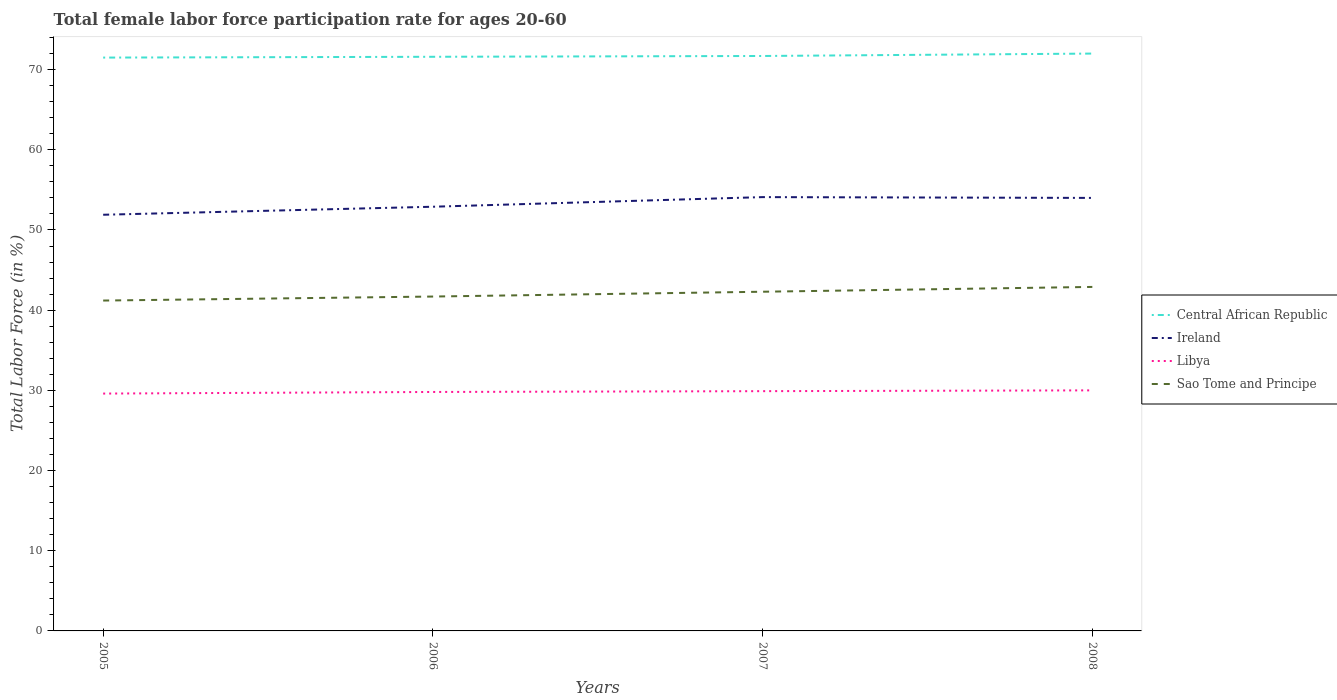How many different coloured lines are there?
Your answer should be compact. 4. Does the line corresponding to Ireland intersect with the line corresponding to Sao Tome and Principe?
Your response must be concise. No. Across all years, what is the maximum female labor force participation rate in Central African Republic?
Give a very brief answer. 71.5. What is the total female labor force participation rate in Sao Tome and Principe in the graph?
Offer a terse response. -0.5. What is the difference between the highest and the second highest female labor force participation rate in Sao Tome and Principe?
Your response must be concise. 1.7. Is the female labor force participation rate in Central African Republic strictly greater than the female labor force participation rate in Ireland over the years?
Provide a short and direct response. No. How many lines are there?
Your answer should be very brief. 4. How many years are there in the graph?
Offer a terse response. 4. How are the legend labels stacked?
Your answer should be compact. Vertical. What is the title of the graph?
Your answer should be very brief. Total female labor force participation rate for ages 20-60. Does "Indonesia" appear as one of the legend labels in the graph?
Provide a short and direct response. No. What is the label or title of the X-axis?
Give a very brief answer. Years. What is the label or title of the Y-axis?
Provide a succinct answer. Total Labor Force (in %). What is the Total Labor Force (in %) in Central African Republic in 2005?
Offer a terse response. 71.5. What is the Total Labor Force (in %) in Ireland in 2005?
Give a very brief answer. 51.9. What is the Total Labor Force (in %) in Libya in 2005?
Your response must be concise. 29.6. What is the Total Labor Force (in %) in Sao Tome and Principe in 2005?
Offer a very short reply. 41.2. What is the Total Labor Force (in %) in Central African Republic in 2006?
Your answer should be very brief. 71.6. What is the Total Labor Force (in %) of Ireland in 2006?
Ensure brevity in your answer.  52.9. What is the Total Labor Force (in %) in Libya in 2006?
Provide a succinct answer. 29.8. What is the Total Labor Force (in %) in Sao Tome and Principe in 2006?
Ensure brevity in your answer.  41.7. What is the Total Labor Force (in %) of Central African Republic in 2007?
Provide a succinct answer. 71.7. What is the Total Labor Force (in %) of Ireland in 2007?
Your answer should be compact. 54.1. What is the Total Labor Force (in %) of Libya in 2007?
Make the answer very short. 29.9. What is the Total Labor Force (in %) in Sao Tome and Principe in 2007?
Your response must be concise. 42.3. What is the Total Labor Force (in %) of Central African Republic in 2008?
Provide a short and direct response. 72. What is the Total Labor Force (in %) in Libya in 2008?
Give a very brief answer. 30. What is the Total Labor Force (in %) in Sao Tome and Principe in 2008?
Offer a terse response. 42.9. Across all years, what is the maximum Total Labor Force (in %) in Central African Republic?
Provide a short and direct response. 72. Across all years, what is the maximum Total Labor Force (in %) in Ireland?
Give a very brief answer. 54.1. Across all years, what is the maximum Total Labor Force (in %) of Sao Tome and Principe?
Your answer should be compact. 42.9. Across all years, what is the minimum Total Labor Force (in %) in Central African Republic?
Provide a short and direct response. 71.5. Across all years, what is the minimum Total Labor Force (in %) in Ireland?
Give a very brief answer. 51.9. Across all years, what is the minimum Total Labor Force (in %) in Libya?
Keep it short and to the point. 29.6. Across all years, what is the minimum Total Labor Force (in %) in Sao Tome and Principe?
Provide a succinct answer. 41.2. What is the total Total Labor Force (in %) in Central African Republic in the graph?
Keep it short and to the point. 286.8. What is the total Total Labor Force (in %) of Ireland in the graph?
Offer a terse response. 212.9. What is the total Total Labor Force (in %) in Libya in the graph?
Provide a succinct answer. 119.3. What is the total Total Labor Force (in %) in Sao Tome and Principe in the graph?
Your answer should be compact. 168.1. What is the difference between the Total Labor Force (in %) of Central African Republic in 2005 and that in 2006?
Offer a very short reply. -0.1. What is the difference between the Total Labor Force (in %) in Ireland in 2005 and that in 2006?
Give a very brief answer. -1. What is the difference between the Total Labor Force (in %) of Sao Tome and Principe in 2005 and that in 2006?
Offer a terse response. -0.5. What is the difference between the Total Labor Force (in %) in Sao Tome and Principe in 2005 and that in 2007?
Your response must be concise. -1.1. What is the difference between the Total Labor Force (in %) in Ireland in 2005 and that in 2008?
Provide a succinct answer. -2.1. What is the difference between the Total Labor Force (in %) in Sao Tome and Principe in 2005 and that in 2008?
Provide a succinct answer. -1.7. What is the difference between the Total Labor Force (in %) in Ireland in 2006 and that in 2007?
Give a very brief answer. -1.2. What is the difference between the Total Labor Force (in %) of Libya in 2006 and that in 2007?
Your answer should be very brief. -0.1. What is the difference between the Total Labor Force (in %) in Sao Tome and Principe in 2006 and that in 2007?
Your answer should be compact. -0.6. What is the difference between the Total Labor Force (in %) of Central African Republic in 2006 and that in 2008?
Offer a terse response. -0.4. What is the difference between the Total Labor Force (in %) in Ireland in 2006 and that in 2008?
Offer a terse response. -1.1. What is the difference between the Total Labor Force (in %) in Libya in 2006 and that in 2008?
Offer a terse response. -0.2. What is the difference between the Total Labor Force (in %) in Central African Republic in 2007 and that in 2008?
Ensure brevity in your answer.  -0.3. What is the difference between the Total Labor Force (in %) of Central African Republic in 2005 and the Total Labor Force (in %) of Libya in 2006?
Provide a short and direct response. 41.7. What is the difference between the Total Labor Force (in %) in Central African Republic in 2005 and the Total Labor Force (in %) in Sao Tome and Principe in 2006?
Offer a terse response. 29.8. What is the difference between the Total Labor Force (in %) in Ireland in 2005 and the Total Labor Force (in %) in Libya in 2006?
Offer a very short reply. 22.1. What is the difference between the Total Labor Force (in %) of Libya in 2005 and the Total Labor Force (in %) of Sao Tome and Principe in 2006?
Your answer should be very brief. -12.1. What is the difference between the Total Labor Force (in %) in Central African Republic in 2005 and the Total Labor Force (in %) in Libya in 2007?
Your response must be concise. 41.6. What is the difference between the Total Labor Force (in %) of Central African Republic in 2005 and the Total Labor Force (in %) of Sao Tome and Principe in 2007?
Offer a very short reply. 29.2. What is the difference between the Total Labor Force (in %) in Ireland in 2005 and the Total Labor Force (in %) in Sao Tome and Principe in 2007?
Ensure brevity in your answer.  9.6. What is the difference between the Total Labor Force (in %) of Central African Republic in 2005 and the Total Labor Force (in %) of Ireland in 2008?
Keep it short and to the point. 17.5. What is the difference between the Total Labor Force (in %) in Central African Republic in 2005 and the Total Labor Force (in %) in Libya in 2008?
Offer a terse response. 41.5. What is the difference between the Total Labor Force (in %) of Central African Republic in 2005 and the Total Labor Force (in %) of Sao Tome and Principe in 2008?
Your response must be concise. 28.6. What is the difference between the Total Labor Force (in %) of Ireland in 2005 and the Total Labor Force (in %) of Libya in 2008?
Your answer should be compact. 21.9. What is the difference between the Total Labor Force (in %) of Libya in 2005 and the Total Labor Force (in %) of Sao Tome and Principe in 2008?
Give a very brief answer. -13.3. What is the difference between the Total Labor Force (in %) in Central African Republic in 2006 and the Total Labor Force (in %) in Ireland in 2007?
Offer a very short reply. 17.5. What is the difference between the Total Labor Force (in %) in Central African Republic in 2006 and the Total Labor Force (in %) in Libya in 2007?
Keep it short and to the point. 41.7. What is the difference between the Total Labor Force (in %) in Central African Republic in 2006 and the Total Labor Force (in %) in Sao Tome and Principe in 2007?
Your response must be concise. 29.3. What is the difference between the Total Labor Force (in %) of Ireland in 2006 and the Total Labor Force (in %) of Libya in 2007?
Provide a short and direct response. 23. What is the difference between the Total Labor Force (in %) in Ireland in 2006 and the Total Labor Force (in %) in Sao Tome and Principe in 2007?
Keep it short and to the point. 10.6. What is the difference between the Total Labor Force (in %) of Central African Republic in 2006 and the Total Labor Force (in %) of Libya in 2008?
Your response must be concise. 41.6. What is the difference between the Total Labor Force (in %) in Central African Republic in 2006 and the Total Labor Force (in %) in Sao Tome and Principe in 2008?
Provide a short and direct response. 28.7. What is the difference between the Total Labor Force (in %) in Ireland in 2006 and the Total Labor Force (in %) in Libya in 2008?
Your answer should be compact. 22.9. What is the difference between the Total Labor Force (in %) in Central African Republic in 2007 and the Total Labor Force (in %) in Libya in 2008?
Give a very brief answer. 41.7. What is the difference between the Total Labor Force (in %) of Central African Republic in 2007 and the Total Labor Force (in %) of Sao Tome and Principe in 2008?
Ensure brevity in your answer.  28.8. What is the difference between the Total Labor Force (in %) in Ireland in 2007 and the Total Labor Force (in %) in Libya in 2008?
Provide a succinct answer. 24.1. What is the difference between the Total Labor Force (in %) in Libya in 2007 and the Total Labor Force (in %) in Sao Tome and Principe in 2008?
Your answer should be compact. -13. What is the average Total Labor Force (in %) in Central African Republic per year?
Make the answer very short. 71.7. What is the average Total Labor Force (in %) of Ireland per year?
Keep it short and to the point. 53.23. What is the average Total Labor Force (in %) in Libya per year?
Give a very brief answer. 29.82. What is the average Total Labor Force (in %) in Sao Tome and Principe per year?
Make the answer very short. 42.02. In the year 2005, what is the difference between the Total Labor Force (in %) in Central African Republic and Total Labor Force (in %) in Ireland?
Ensure brevity in your answer.  19.6. In the year 2005, what is the difference between the Total Labor Force (in %) of Central African Republic and Total Labor Force (in %) of Libya?
Your answer should be compact. 41.9. In the year 2005, what is the difference between the Total Labor Force (in %) in Central African Republic and Total Labor Force (in %) in Sao Tome and Principe?
Your answer should be very brief. 30.3. In the year 2005, what is the difference between the Total Labor Force (in %) in Ireland and Total Labor Force (in %) in Libya?
Ensure brevity in your answer.  22.3. In the year 2005, what is the difference between the Total Labor Force (in %) of Ireland and Total Labor Force (in %) of Sao Tome and Principe?
Keep it short and to the point. 10.7. In the year 2005, what is the difference between the Total Labor Force (in %) in Libya and Total Labor Force (in %) in Sao Tome and Principe?
Offer a very short reply. -11.6. In the year 2006, what is the difference between the Total Labor Force (in %) in Central African Republic and Total Labor Force (in %) in Ireland?
Ensure brevity in your answer.  18.7. In the year 2006, what is the difference between the Total Labor Force (in %) of Central African Republic and Total Labor Force (in %) of Libya?
Keep it short and to the point. 41.8. In the year 2006, what is the difference between the Total Labor Force (in %) in Central African Republic and Total Labor Force (in %) in Sao Tome and Principe?
Your answer should be very brief. 29.9. In the year 2006, what is the difference between the Total Labor Force (in %) in Ireland and Total Labor Force (in %) in Libya?
Provide a short and direct response. 23.1. In the year 2006, what is the difference between the Total Labor Force (in %) of Ireland and Total Labor Force (in %) of Sao Tome and Principe?
Provide a short and direct response. 11.2. In the year 2007, what is the difference between the Total Labor Force (in %) in Central African Republic and Total Labor Force (in %) in Libya?
Ensure brevity in your answer.  41.8. In the year 2007, what is the difference between the Total Labor Force (in %) of Central African Republic and Total Labor Force (in %) of Sao Tome and Principe?
Offer a terse response. 29.4. In the year 2007, what is the difference between the Total Labor Force (in %) in Ireland and Total Labor Force (in %) in Libya?
Provide a succinct answer. 24.2. In the year 2007, what is the difference between the Total Labor Force (in %) in Ireland and Total Labor Force (in %) in Sao Tome and Principe?
Your response must be concise. 11.8. In the year 2008, what is the difference between the Total Labor Force (in %) of Central African Republic and Total Labor Force (in %) of Libya?
Ensure brevity in your answer.  42. In the year 2008, what is the difference between the Total Labor Force (in %) in Central African Republic and Total Labor Force (in %) in Sao Tome and Principe?
Keep it short and to the point. 29.1. In the year 2008, what is the difference between the Total Labor Force (in %) in Ireland and Total Labor Force (in %) in Libya?
Keep it short and to the point. 24. In the year 2008, what is the difference between the Total Labor Force (in %) in Ireland and Total Labor Force (in %) in Sao Tome and Principe?
Make the answer very short. 11.1. In the year 2008, what is the difference between the Total Labor Force (in %) of Libya and Total Labor Force (in %) of Sao Tome and Principe?
Make the answer very short. -12.9. What is the ratio of the Total Labor Force (in %) in Ireland in 2005 to that in 2006?
Ensure brevity in your answer.  0.98. What is the ratio of the Total Labor Force (in %) of Libya in 2005 to that in 2006?
Your answer should be compact. 0.99. What is the ratio of the Total Labor Force (in %) of Ireland in 2005 to that in 2007?
Ensure brevity in your answer.  0.96. What is the ratio of the Total Labor Force (in %) of Libya in 2005 to that in 2007?
Your answer should be compact. 0.99. What is the ratio of the Total Labor Force (in %) in Sao Tome and Principe in 2005 to that in 2007?
Provide a short and direct response. 0.97. What is the ratio of the Total Labor Force (in %) in Central African Republic in 2005 to that in 2008?
Ensure brevity in your answer.  0.99. What is the ratio of the Total Labor Force (in %) of Ireland in 2005 to that in 2008?
Keep it short and to the point. 0.96. What is the ratio of the Total Labor Force (in %) of Libya in 2005 to that in 2008?
Your answer should be compact. 0.99. What is the ratio of the Total Labor Force (in %) of Sao Tome and Principe in 2005 to that in 2008?
Your response must be concise. 0.96. What is the ratio of the Total Labor Force (in %) of Central African Republic in 2006 to that in 2007?
Keep it short and to the point. 1. What is the ratio of the Total Labor Force (in %) of Ireland in 2006 to that in 2007?
Offer a terse response. 0.98. What is the ratio of the Total Labor Force (in %) of Sao Tome and Principe in 2006 to that in 2007?
Keep it short and to the point. 0.99. What is the ratio of the Total Labor Force (in %) of Central African Republic in 2006 to that in 2008?
Your answer should be compact. 0.99. What is the ratio of the Total Labor Force (in %) in Ireland in 2006 to that in 2008?
Provide a short and direct response. 0.98. What is the ratio of the Total Labor Force (in %) of Sao Tome and Principe in 2006 to that in 2008?
Give a very brief answer. 0.97. What is the ratio of the Total Labor Force (in %) in Central African Republic in 2007 to that in 2008?
Make the answer very short. 1. What is the ratio of the Total Labor Force (in %) of Ireland in 2007 to that in 2008?
Make the answer very short. 1. What is the difference between the highest and the second highest Total Labor Force (in %) in Central African Republic?
Provide a succinct answer. 0.3. What is the difference between the highest and the second highest Total Labor Force (in %) of Ireland?
Your response must be concise. 0.1. What is the difference between the highest and the lowest Total Labor Force (in %) in Central African Republic?
Offer a terse response. 0.5. What is the difference between the highest and the lowest Total Labor Force (in %) in Ireland?
Give a very brief answer. 2.2. What is the difference between the highest and the lowest Total Labor Force (in %) of Sao Tome and Principe?
Your response must be concise. 1.7. 